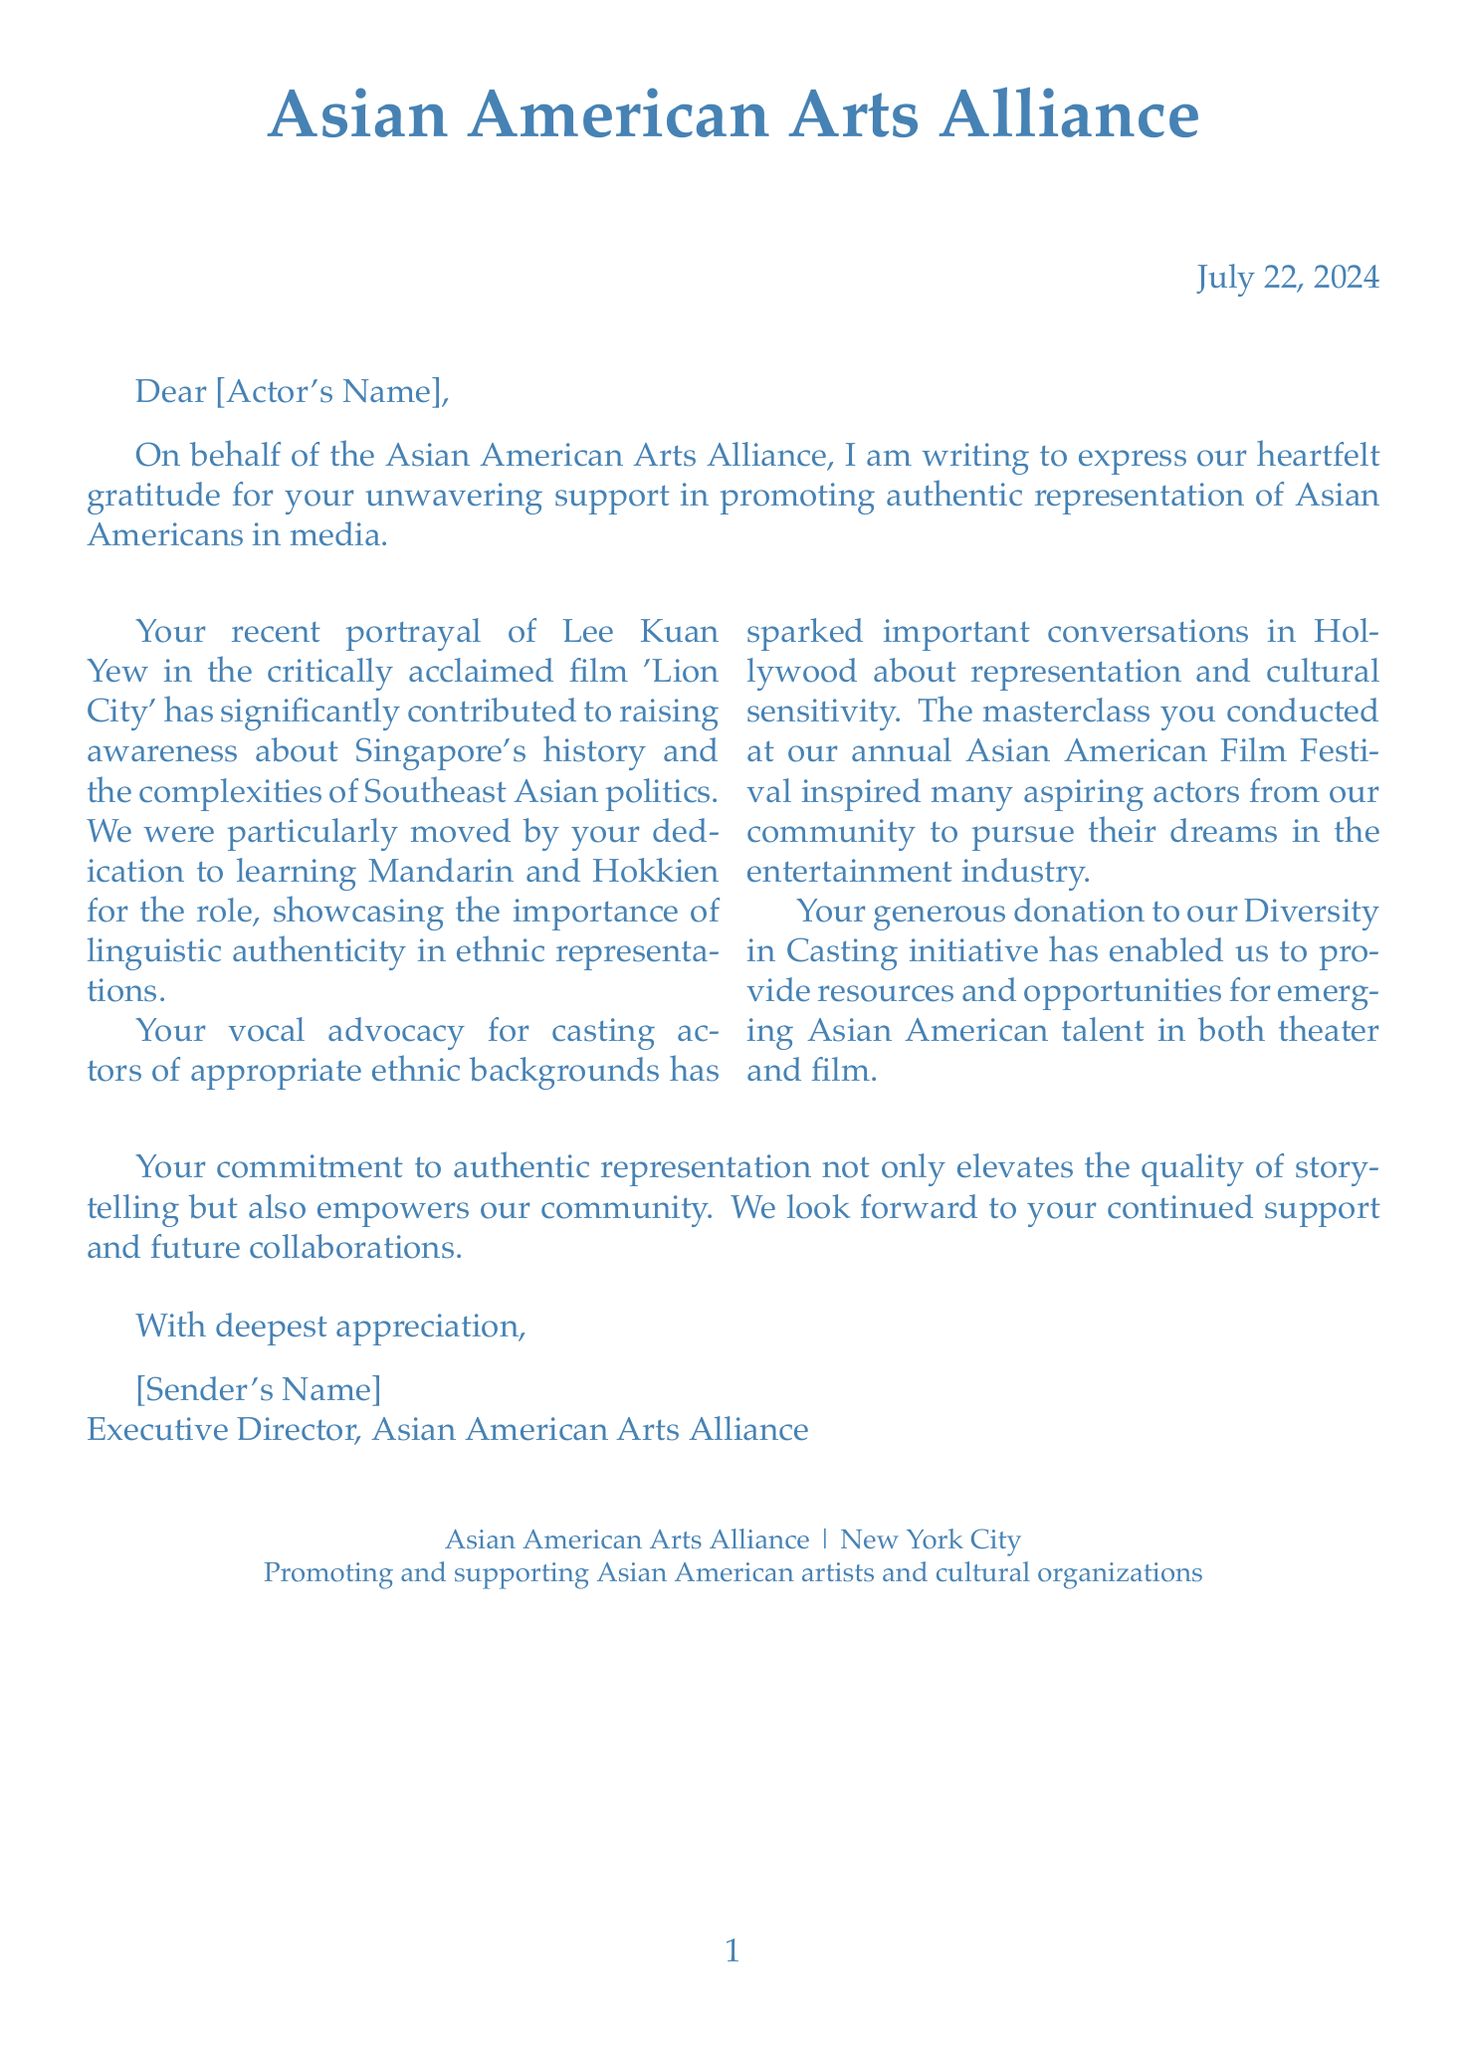What is the name of the organization sending the letter? The letter is from the Asian American Arts Alliance as stated in the document.
Answer: Asian American Arts Alliance What recent film role is mentioned in the letter? The letter refers to the actor's portrayal of Lee Kuan Yew in 'Lion City'.
Answer: Lee Kuan Yew in 'Lion City' Which languages did the actor learn for their role? The document specifically mentions the actor learning Mandarin and Hokkien for their recent role.
Answer: Mandarin and Hokkien What initiative did the actor donate to? The letter mentions a donation made to the Diversity in Casting initiative.
Answer: Diversity in Casting initiative What was conducted at the Asian American Film Festival? The document states that the actor conducted a masterclass during the festival.
Answer: A masterclass What is one challenge remaining in the industry according to the document? The document states that there is limited roles for Asian American actors beyond stereotypical characters.
Answer: Limited roles for Asian American actors What date is mentioned in the letter? The date is located in the flush right section, indicating when the letter is written.
Answer: Today's date What does the organization aim to promote? The mission of the organization is stated to promote and support Asian American artists and cultural organizations.
Answer: Promote and support Asian American artists and cultural organizations 